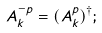<formula> <loc_0><loc_0><loc_500><loc_500>A ^ { - p } _ { k } = ( A ^ { p } _ { k } ) ^ { \dagger } ;</formula> 